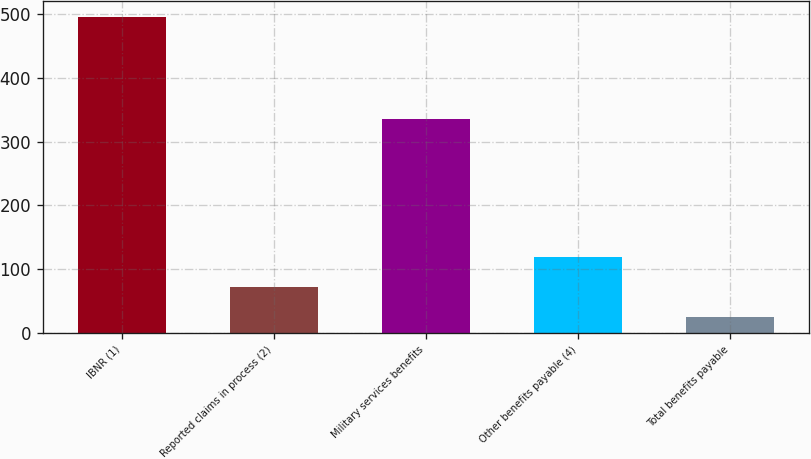Convert chart to OTSL. <chart><loc_0><loc_0><loc_500><loc_500><bar_chart><fcel>IBNR (1)<fcel>Reported claims in process (2)<fcel>Military services benefits<fcel>Other benefits payable (4)<fcel>Total benefits payable<nl><fcel>496<fcel>72.1<fcel>335<fcel>119.2<fcel>25<nl></chart> 